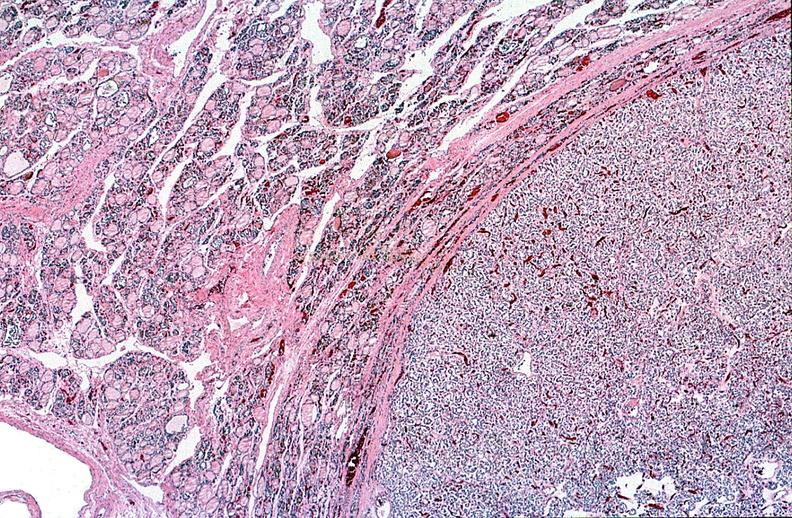what does this image show?
Answer the question using a single word or phrase. Thyroid 